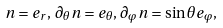<formula> <loc_0><loc_0><loc_500><loc_500>n = e _ { r } , \, \partial _ { \theta } n = e _ { \theta } , \, \partial _ { \varphi } n = \sin \theta e _ { \varphi } ,</formula> 